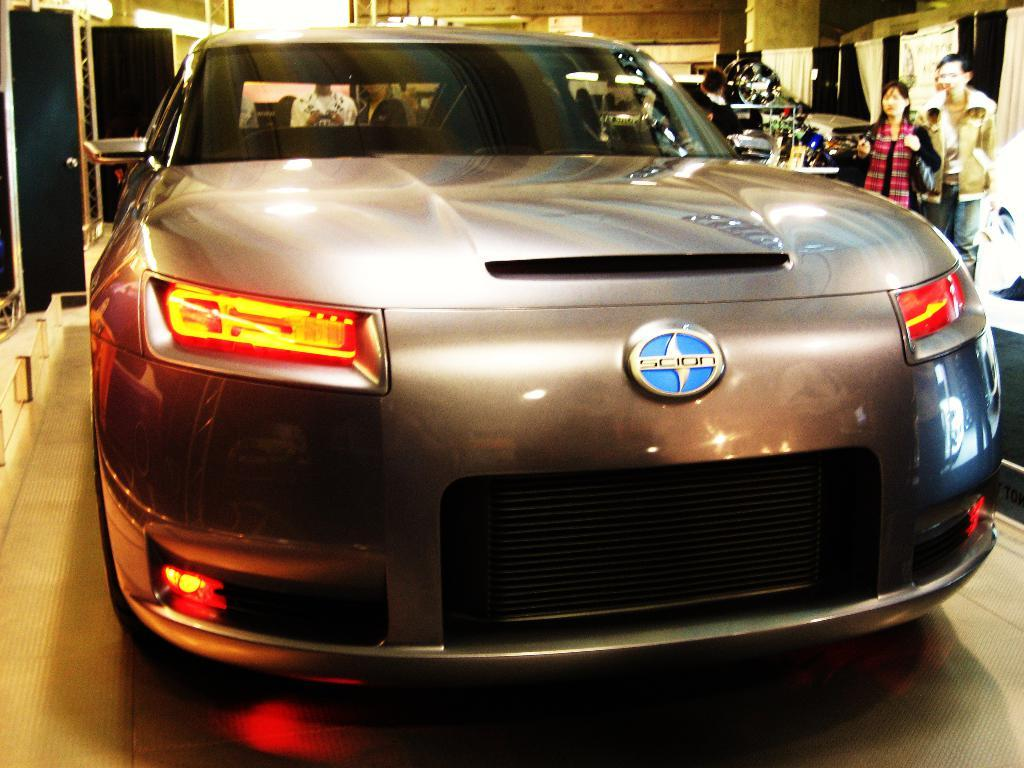What is the main subject of the image? There is a car in the image. Can you describe the color of the car? The car is ash-colored. Are there any other people or objects visible in the image? Yes, there are people visible in the background. What is the surface on which the car is parked? The car is on a brown-colored floor. What type of recess is visible in the image? There is no recess present in the image; it features a car on a brown-colored floor with people visible in the background. Can you hear the people talking in the image? The image is a still picture, so it does not capture any sounds, including the people talking. 